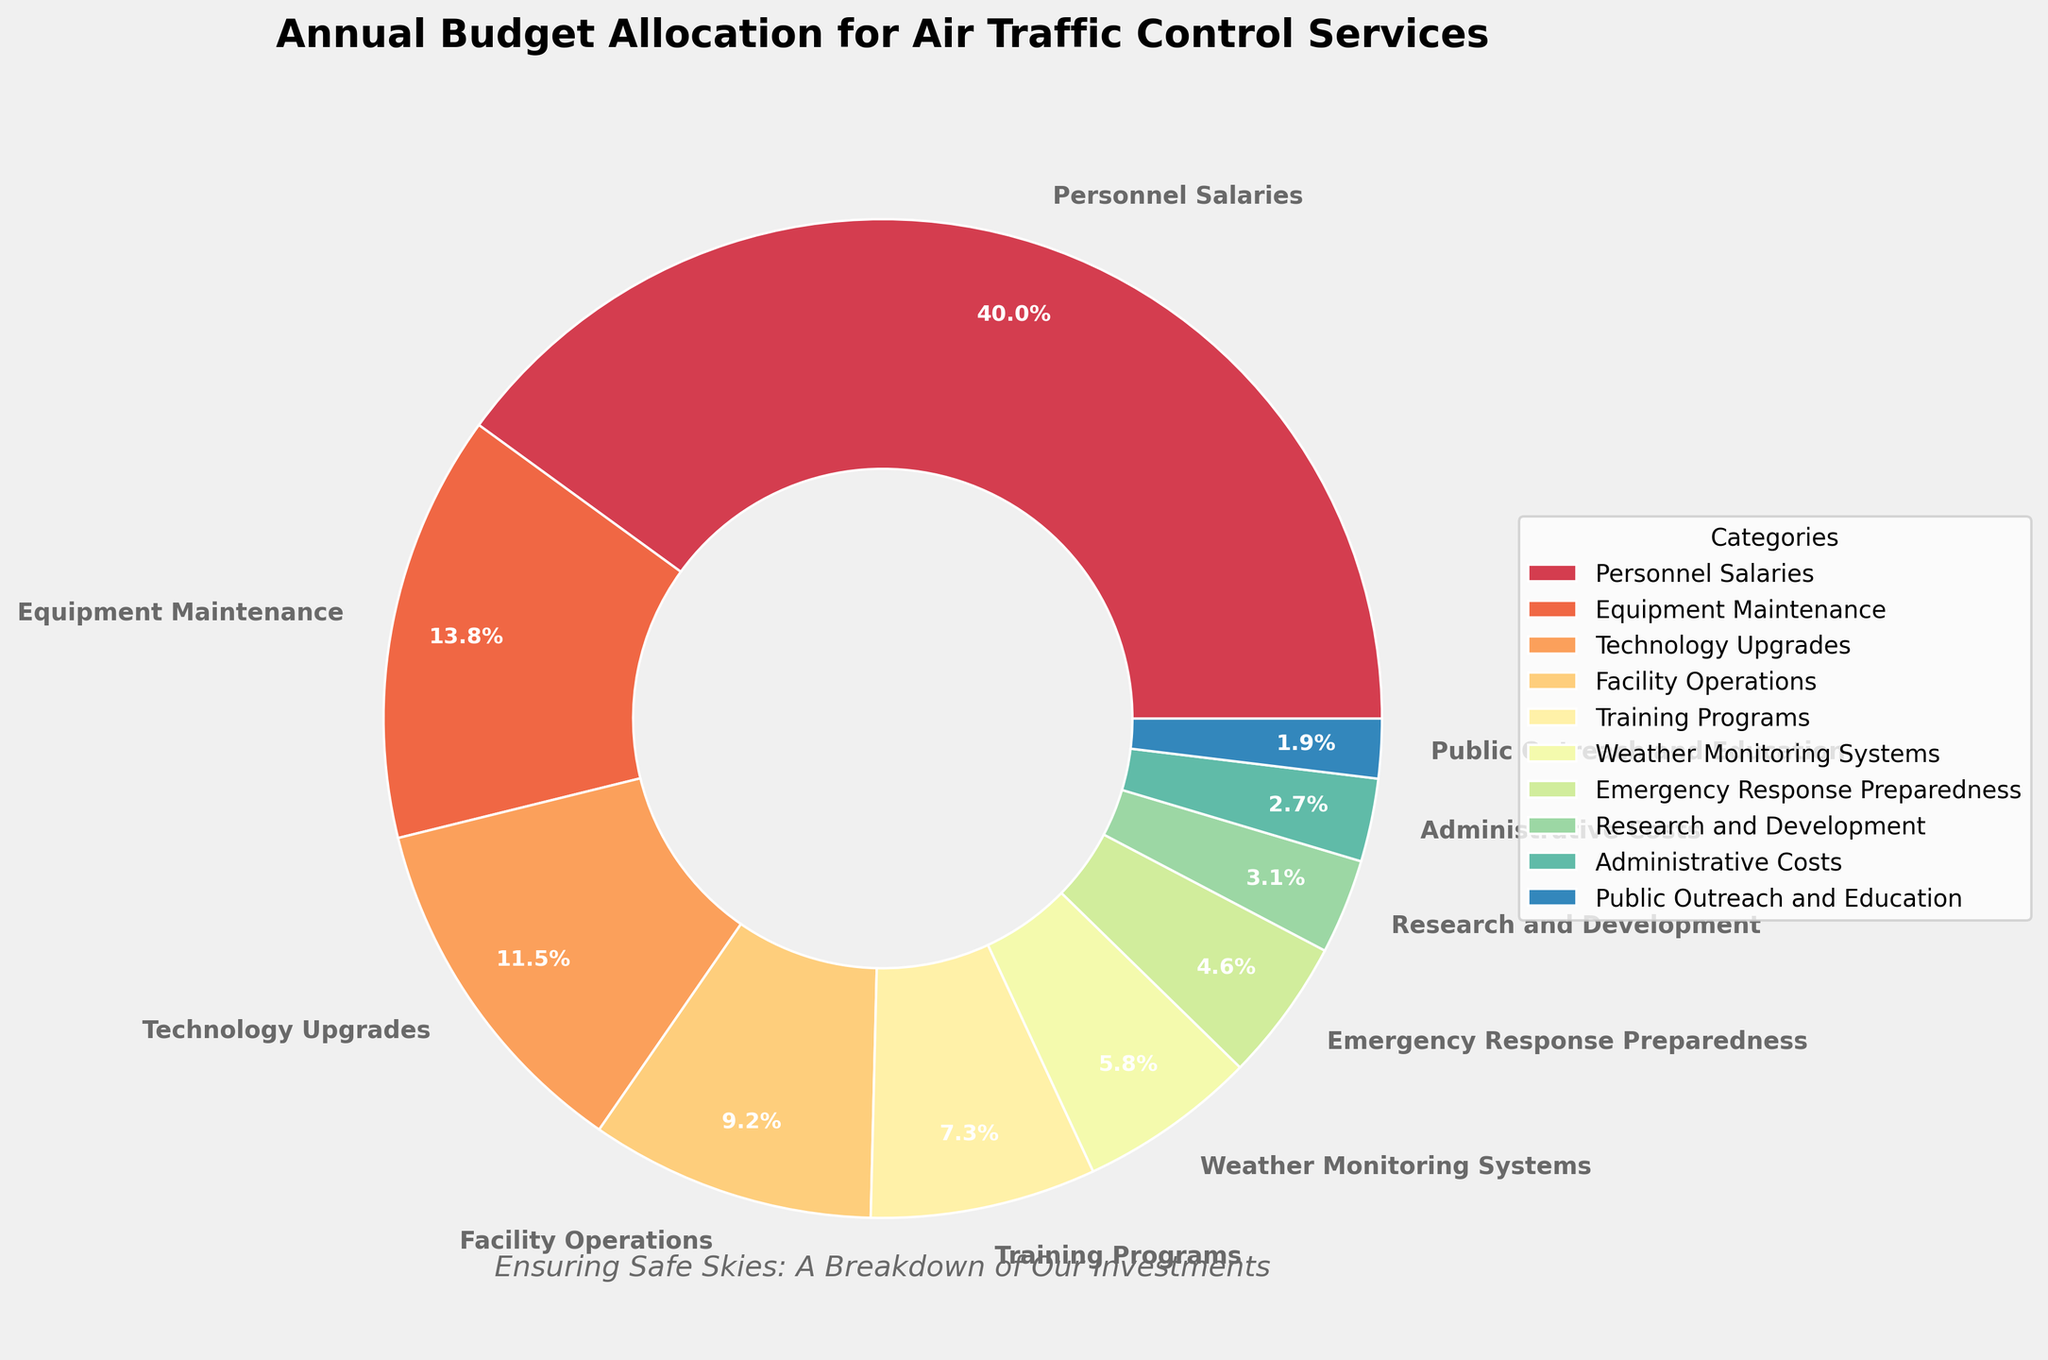what percentage of the total budget is allocated to Personnel Salaries? The pie chart shows the percentages of each category, and Personnel Salaries is indicated as 50.6%
Answer: 50.6% Which category gets the smallest portion of the budget? By examining the pie chart, Research and Development has the smallest slice
Answer: Research and Development What is the combined budget percentage for Technology Upgrades and Equipment Maintenance? Technology Upgrades have 14.6%, and Equipment Maintenance has 17.6%. Adding these together gives 14.6% + 17.6% = 32.2%
Answer: 32.2% How many categories received less than 10% of the budget? From the pie chart, Weather Monitoring Systems, Emergency Response Preparedness, Research and Development, Public Outreach and Education, and Administrative Costs each have less than 10%. There are 5 categories in total
Answer: 5 Which category receives more funding: Facility Operations or Training Programs? From the pie chart, Facility Operations have a larger slice compared to Training Programs
Answer: Facility Operations What is the difference in budget allocation between Personnel Salaries and Technology Upgrades? Personnel Salaries have 50.6% of the total budget, and Technology Upgrades have 14.6%. The difference is 50.6% - 14.6% = 36.0%
Answer: 36.0% What is the average budget percentage for the categories receiving the three largest allocations? The three largest allocations are Personnel Salaries (50.6%), Equipment Maintenance (17.6%), and Technology Upgrades (14.6%). The average is calculated as (50.6% + 17.6% + 14.6%) / 3 = 27.6%
Answer: 27.6% How does the budget for Public Outreach and Education compare to Administrative Costs? Public Outreach and Education is 2.4%, while Administrative Costs are 3.4%. Administrative Costs are higher
Answer: Administrative Costs What are the total percentages of budget allocated for Personnel Salaries, Equipment Maintenance, and Technology Upgrades? Summing Personnel Salaries (50.6%), Equipment Maintenance (17.6%), and Technology Upgrades (14.6%) results in 50.6% + 17.6% + 14.6% = 82.8%
Answer: 82.8% 